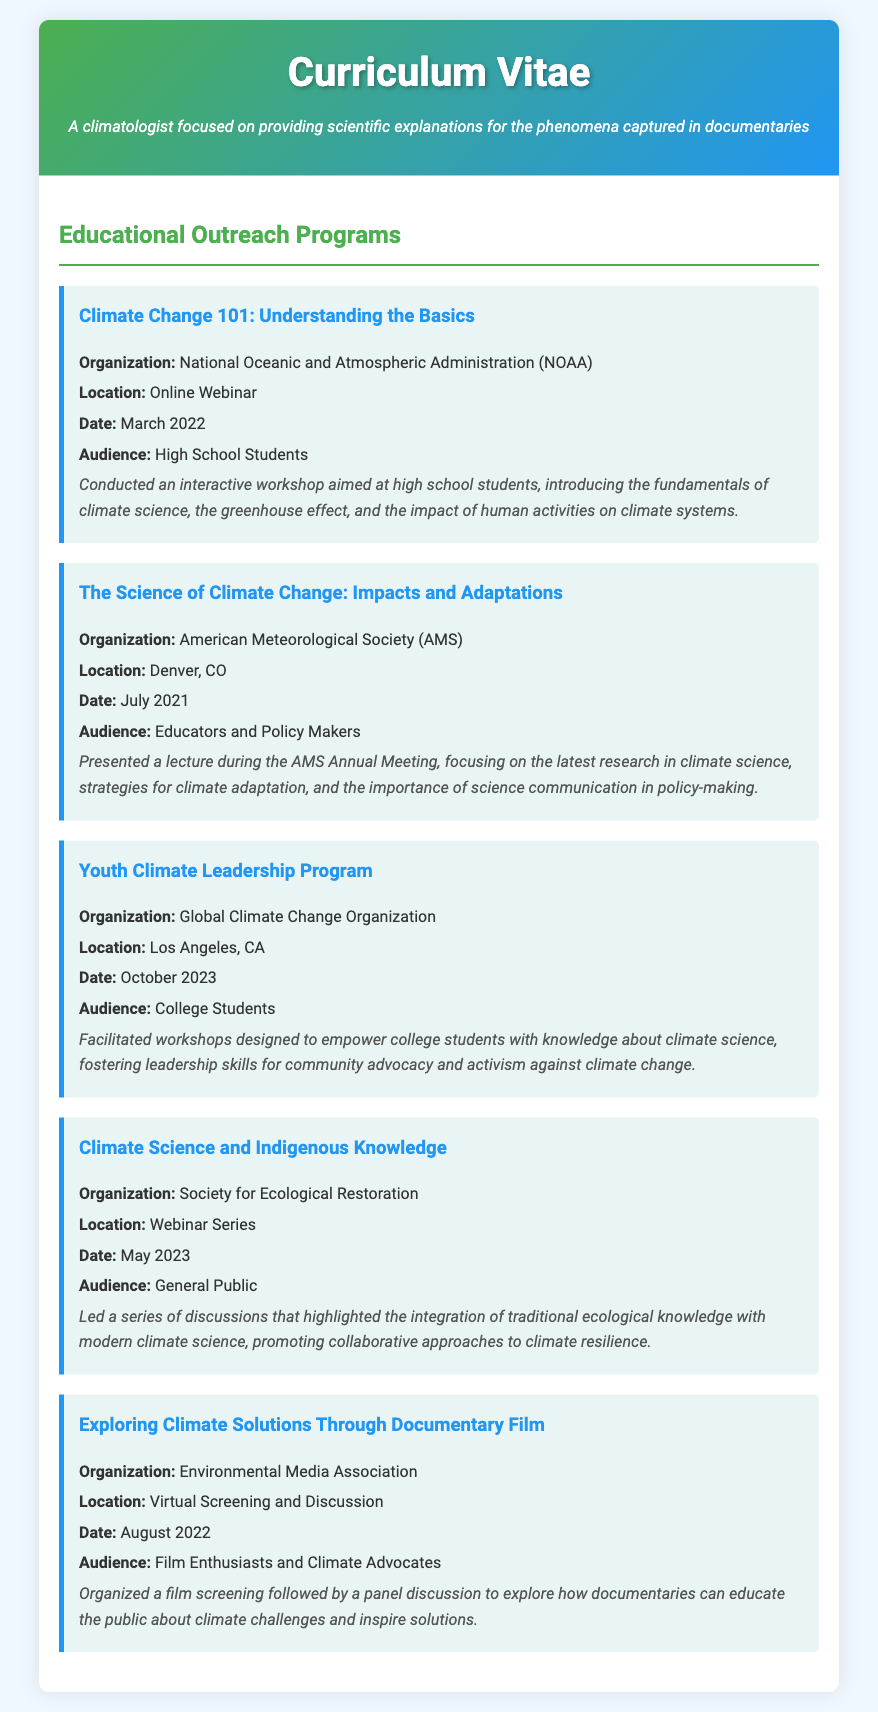What was the date of the workshop "Climate Change 101: Understanding the Basics"? The date of the workshop can be found in the program details, which states it occurred in March 2022.
Answer: March 2022 Who conducted the "Youth Climate Leadership Program"? The document lists the organization responsible for the program, which is the Global Climate Change Organization.
Answer: Global Climate Change Organization What audience was targeted in the "Science of Climate Change: Impacts and Adaptations" lecture? The intended audience for the lecture is specified in the program details as Educators and Policy Makers.
Answer: Educators and Policy Makers What type of event was "Exploring Climate Solutions Through Documentary Film"? The description mentions that it was organized as a film screening followed by a panel discussion.
Answer: Virtual Screening and Discussion Which organization hosted the "Climate Science and Indigenous Knowledge" discussion? The organization responsible for hosting the discussion is mentioned as the Society for Ecological Restoration.
Answer: Society for Ecological Restoration In what location did the "The Science of Climate Change: Impacts and Adaptations" take place? The location for the event can be found in the program details, indicating it was held in Denver, CO.
Answer: Denver, CO What is the main focus of the "Climate Change 101" workshop? The main focus is outlined in the program description, which emphasizes introducing the fundamentals of climate science and the greenhouse effect.
Answer: Understanding the Basics How many educational outreach programs are listed in the document? By counting the individual programs presented, we find that there are a total of five programs listed.
Answer: Five 